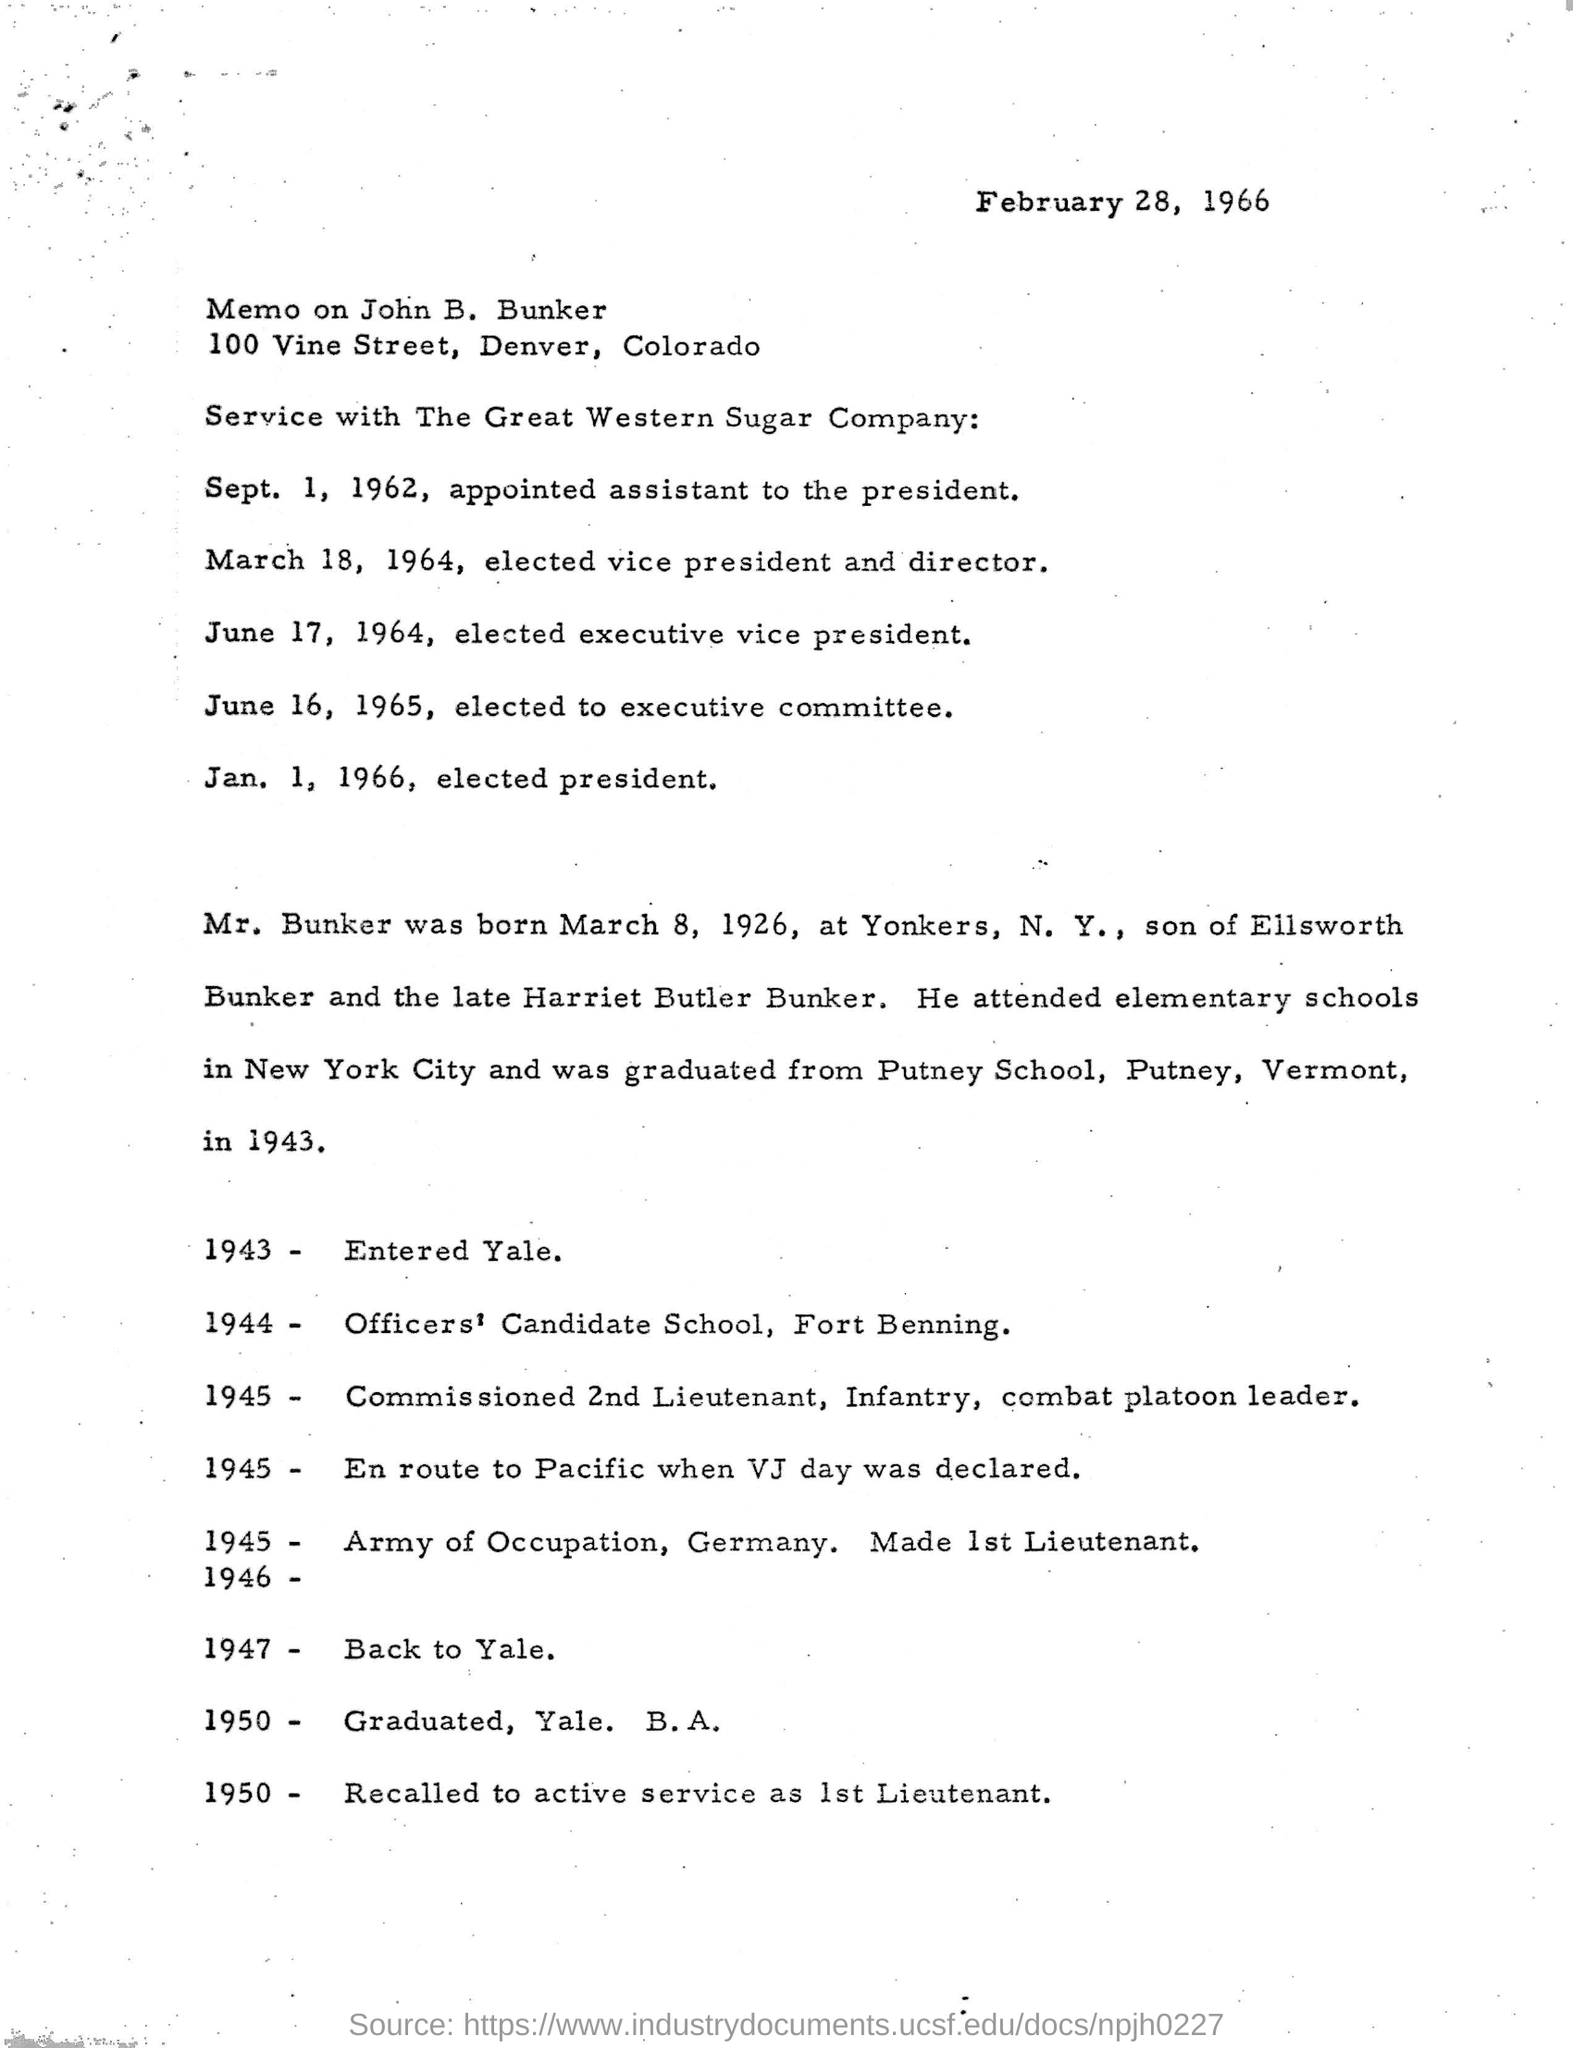Identify some key points in this picture. When he is elected as vice president and director, March 18, 1964, will be a significant date in his life. The memo mentioned in the document was written by John B. Bunker. When did he graduate from Putney School? He graduated in 1943. In 1944, he joined the Officers Candidate School at Fort Benning. John B. Bunker's parents are Ellsworth Bunker and the late Harriet Butler Bunker. 